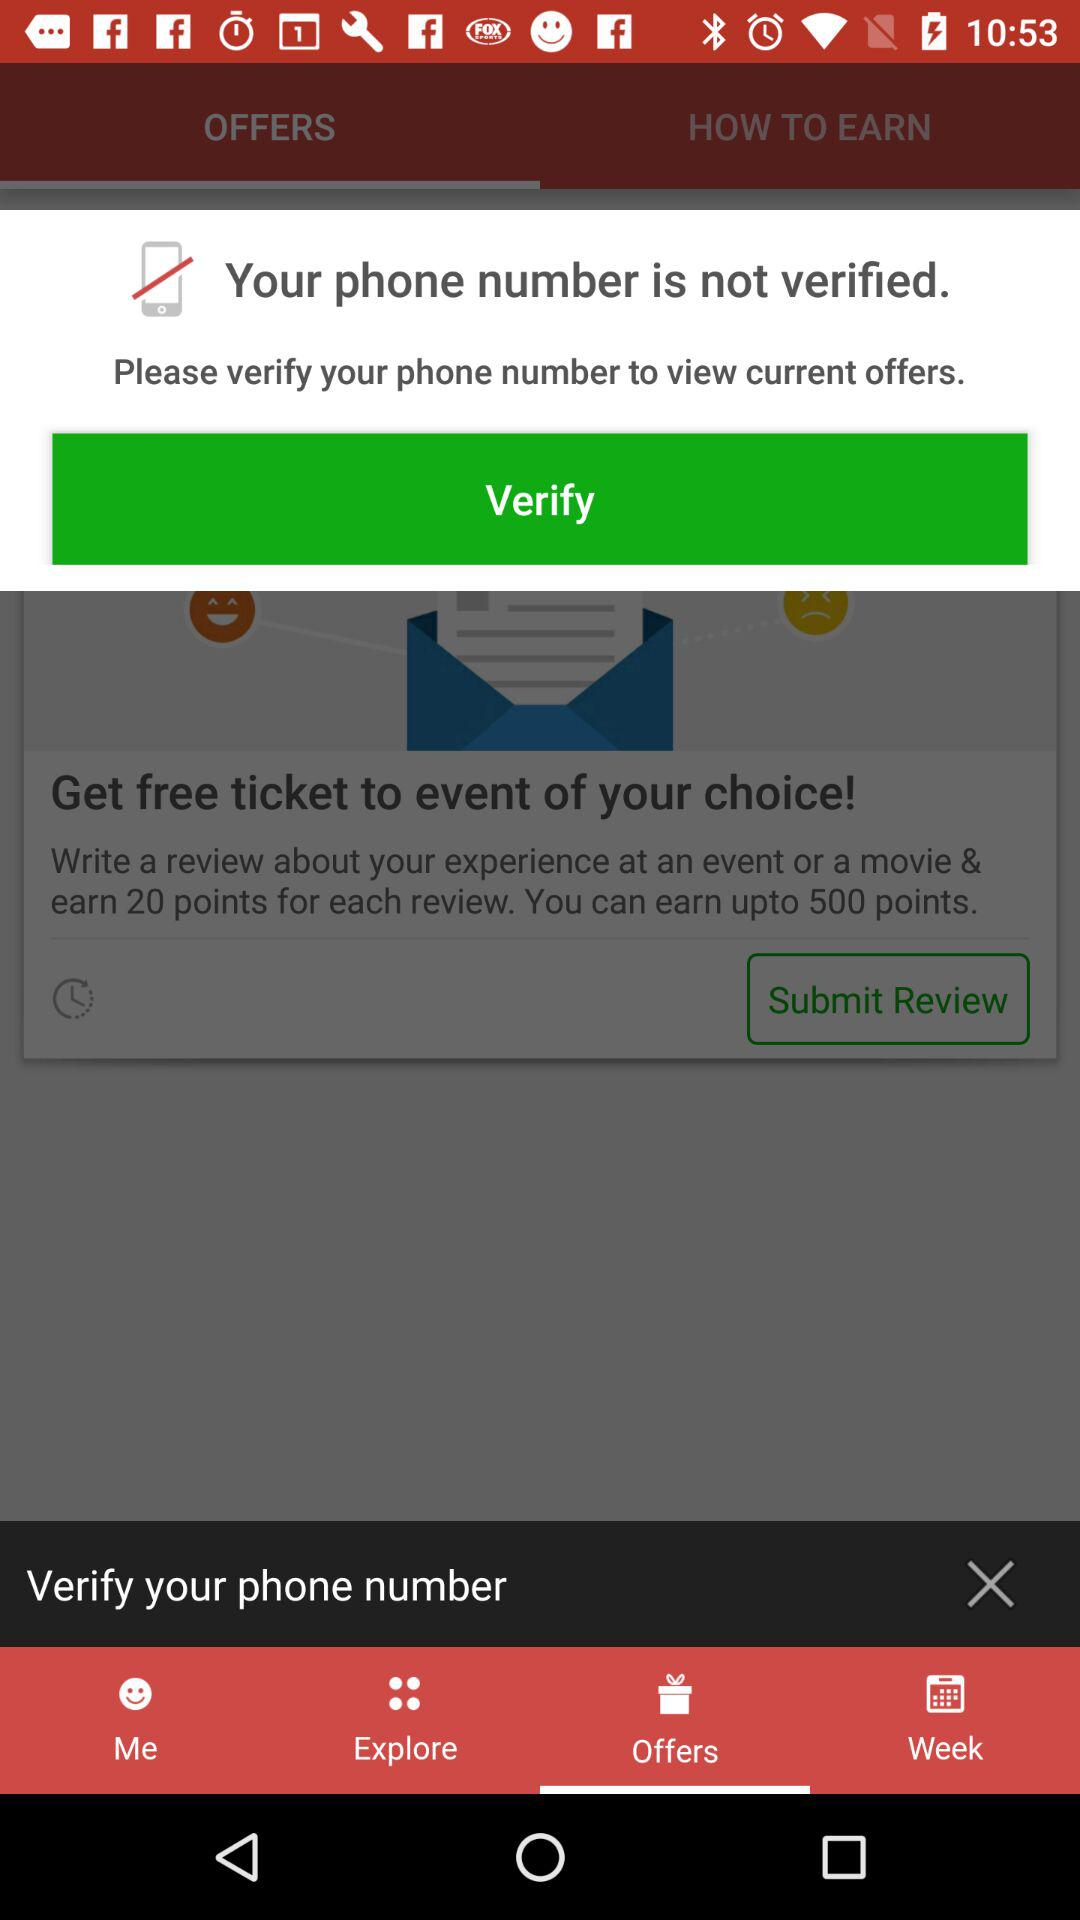How many points do you earn for submitting a review?
Answer the question using a single word or phrase. 20 